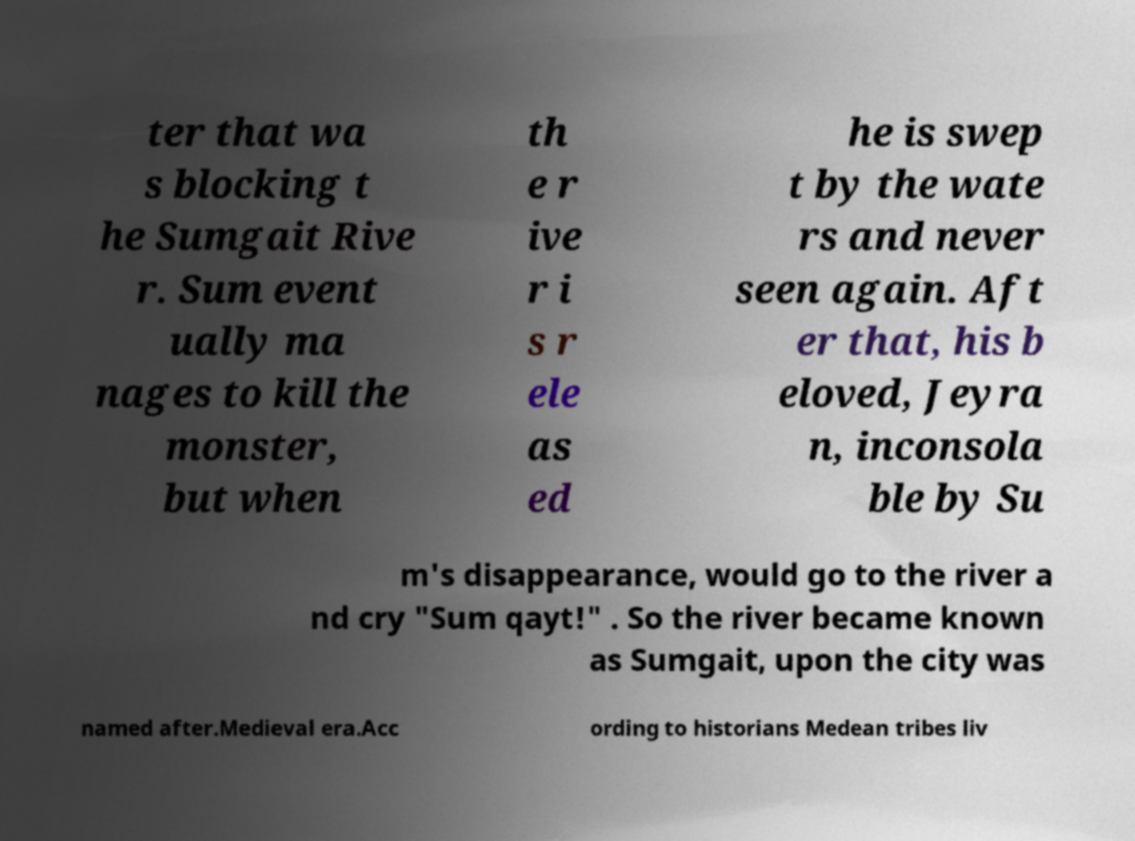Please identify and transcribe the text found in this image. ter that wa s blocking t he Sumgait Rive r. Sum event ually ma nages to kill the monster, but when th e r ive r i s r ele as ed he is swep t by the wate rs and never seen again. Aft er that, his b eloved, Jeyra n, inconsola ble by Su m's disappearance, would go to the river a nd cry "Sum qayt!" . So the river became known as Sumgait, upon the city was named after.Medieval era.Acc ording to historians Medean tribes liv 